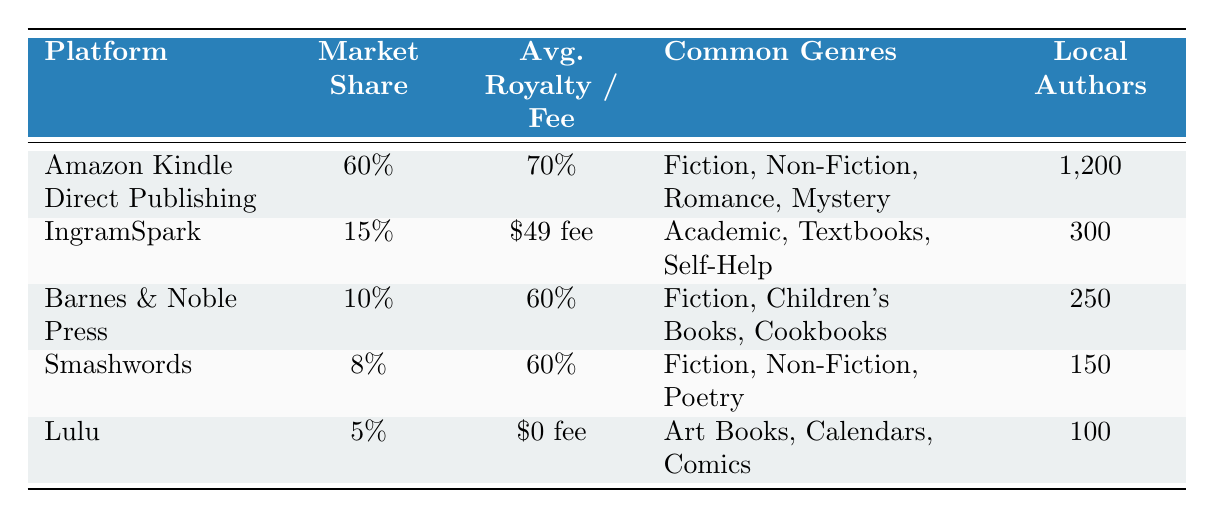What is the market share percentage of Amazon Kindle Direct Publishing? The table shows the market share for each platform. For Amazon Kindle Direct Publishing, it indicates a market share percentage of 60%.
Answer: 60% How many local authors are using IngramSpark? The table lists the number of local authors for each platform, and IngramSpark has 300 local authors using it.
Answer: 300 What is the difference in average royalty percentage between Amazon Kindle Direct Publishing and Barnes & Noble Press? From the table, Amazon Kindle Direct Publishing has an average royalty percentage of 70%, while Barnes & Noble Press has 60%. The difference is calculated as 70% - 60% = 10%.
Answer: 10% Which platform has the lowest market share, and what is that percentage? The table lists the percentages for each platform. Lulu has the lowest market share percentage of 5%.
Answer: 5% Are more local authors using Smashwords than Barnes & Noble Press? Looking at the table, Smashwords has 150 local authors while Barnes & Noble Press has 250 authors. Therefore, there are fewer authors using Smashwords.
Answer: No How many more local authors are using Amazon Kindle Direct Publishing compared to Lulu? From the table, Amazon Kindle Direct Publishing has 1,200 local authors, and Lulu has 100 local authors. The difference is calculated as 1,200 - 100 = 1,100.
Answer: 1,100 What genres are associated with IngramSpark? IngramSpark's common genres are explicitly listed in the table as Academic, Textbooks, and Self-Help.
Answer: Academic, Textbooks, Self-Help Is there any self-publishing platform listed that has no associated fees? The table indicates that Lulu has an average fee of $0, which means it does not charge any fees for using their platform.
Answer: Yes What is the average royalty percentage across all platforms listed? To find the average royalty percentage, we look at the platforms with royalty values. The average is calculated by adding the percentages (70% + 60% + 60%) from Amazon Kindle Direct Publishing, Barnes & Noble Press, and Smashwords and then dividing by the number of platforms contributing, which is 3. This results in (70 + 60 + 60) / 3 = 630 / 3 = 210, and thus the average royalty percentage is 210 / 3 = 70%.
Answer: 70% 